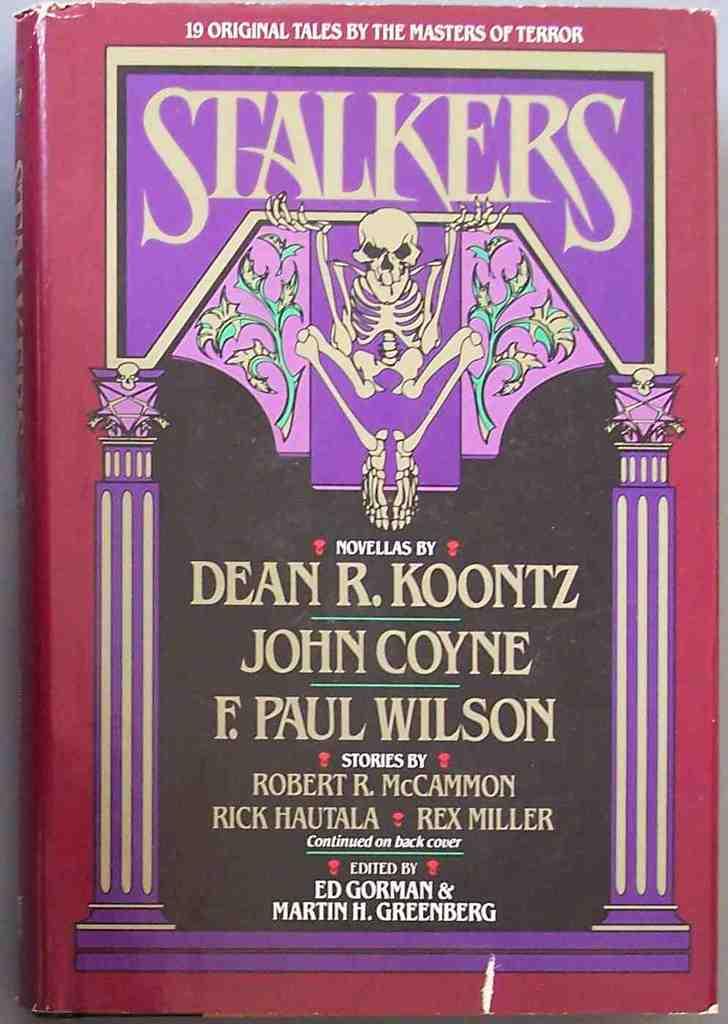How many original tales are in the book?
Keep it short and to the point. 19. What is the title of the book?
Your answer should be very brief. Stalkers. 